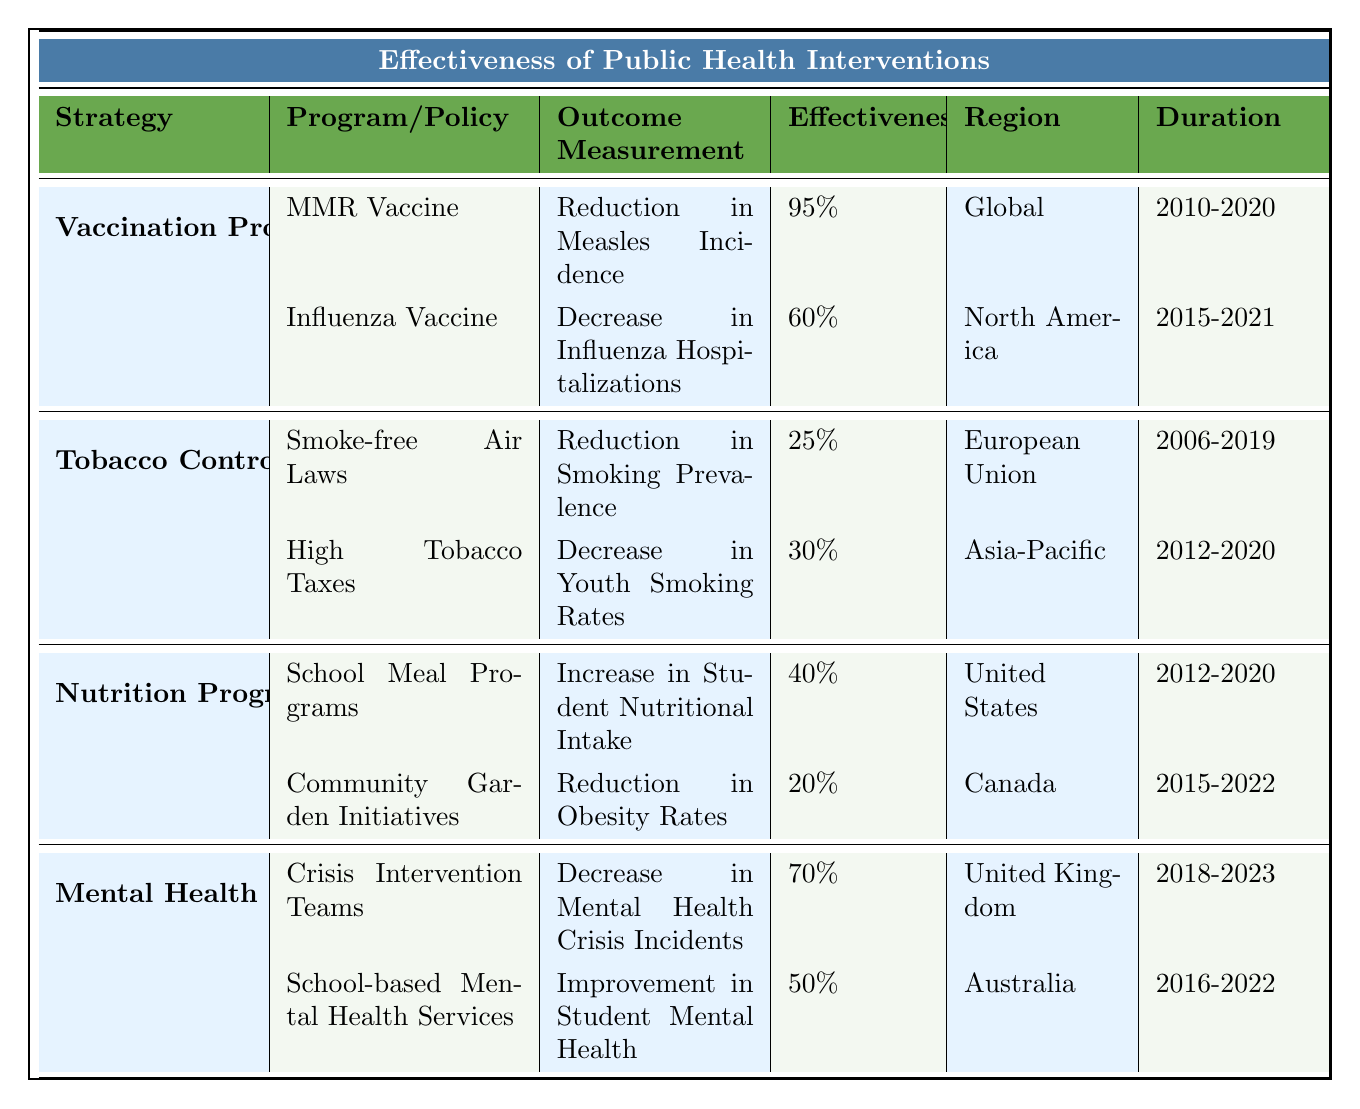What is the effectiveness percentage of the MMR vaccine? The table lists the MMR vaccine under Vaccination Programs, and its effectiveness percentage is specifically stated as 95%.
Answer: 95% Which region implemented the Smoke-free Air Laws? The Smoke-free Air Laws are listed under Tobacco Control Policies, and the region specified in the table is the European Union.
Answer: European Union What is the average effectiveness of the Nutrition Programs? To find the average, we add the effectiveness percentages for School Meal Programs (40%) and Community Garden Initiatives (20%) to get 60%. Then, we divide by 2 (the number of programs): 60% / 2 = 30%.
Answer: 30% Is the effectiveness of the Crisis Intervention Teams greater than 50%? The effectiveness percentage for Crisis Intervention Teams is listed as 70%, which is indeed greater than 50%.
Answer: Yes What is the difference in effectiveness between High Tobacco Taxes and the Influenza Vaccine? The effectiveness of High Tobacco Taxes is 30%, while the Influenza Vaccine is 60%. We calculate the difference: 60% - 30% = 30%.
Answer: 30% Which strategy has the highest effectiveness percentage, and what is it? The table shows that Vaccination Programs, specifically the MMR vaccine, has the highest effectiveness at 95%.
Answer: Vaccination Programs (95%) How many strategies are listed in the table? The table outlines four strategies: Vaccination Programs, Tobacco Control Policies, Nutrition Programs, and Mental Health Initiatives. Therefore, there are four strategies in total.
Answer: 4 What is the effectiveness of Community Garden Initiatives? The effectiveness percentage for Community Garden Initiatives is indicated as 20% in the table.
Answer: 20% Which intervention had the longest duration based on the table? The Vaccination Programs (pertaining to the MMR vaccine) and the effectiveness measurement lasted from 2010 to 2020, making it the longest duration listed in the table.
Answer: Vaccination Programs (10 years) If we sum the effectiveness percentages of all Mental Health Initiatives, what do we get? The effectiveness percentages for the two Mental Health Initiatives are 70% and 50%. Summing these gives us 70% + 50% = 120%.
Answer: 120% 